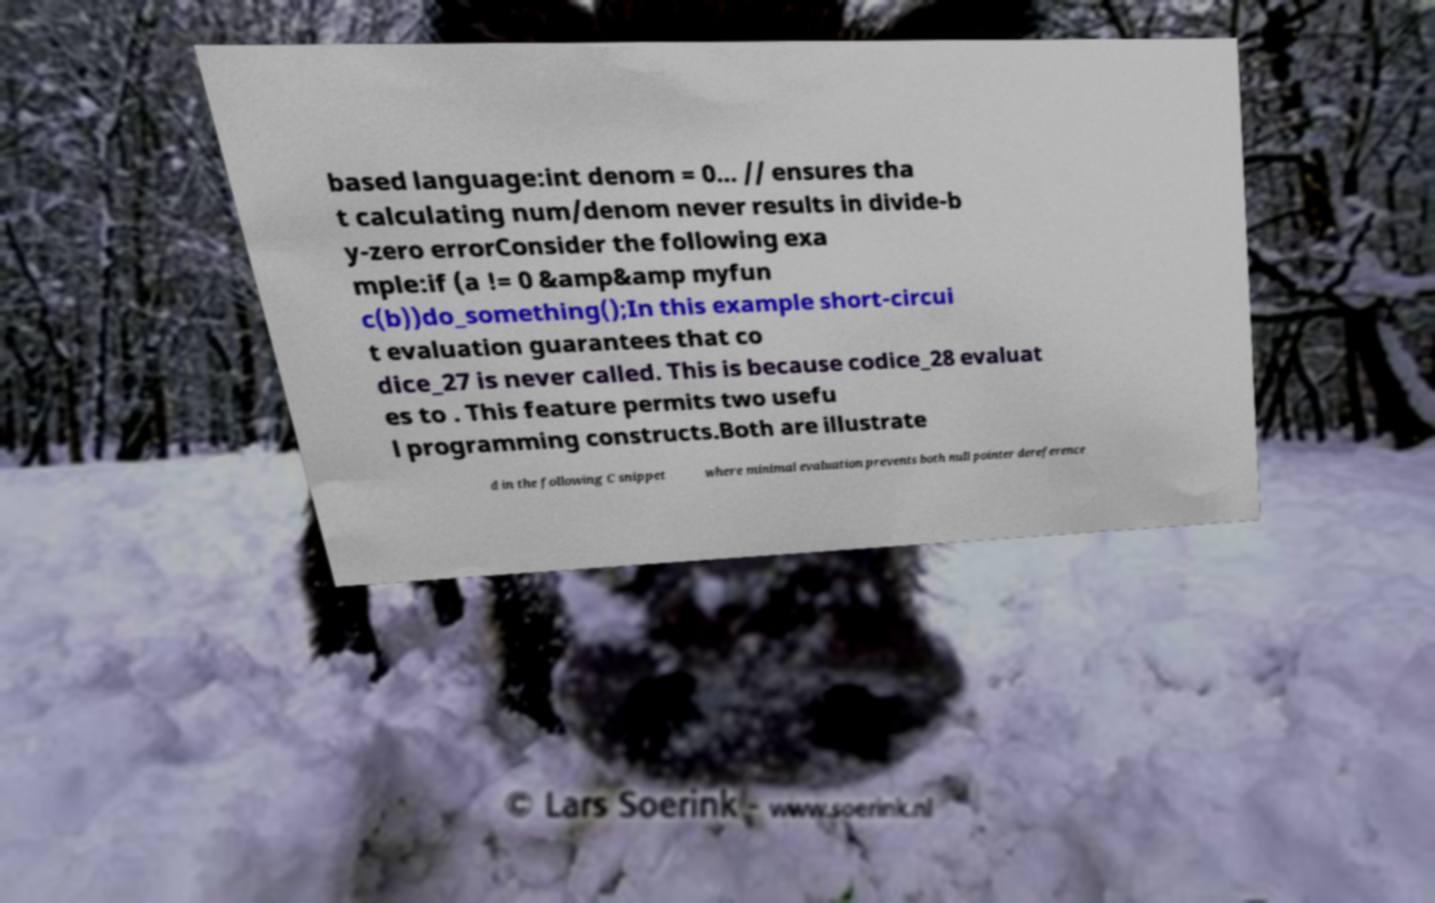There's text embedded in this image that I need extracted. Can you transcribe it verbatim? based language:int denom = 0... // ensures tha t calculating num/denom never results in divide-b y-zero errorConsider the following exa mple:if (a != 0 &amp&amp myfun c(b))do_something();In this example short-circui t evaluation guarantees that co dice_27 is never called. This is because codice_28 evaluat es to . This feature permits two usefu l programming constructs.Both are illustrate d in the following C snippet where minimal evaluation prevents both null pointer dereference 